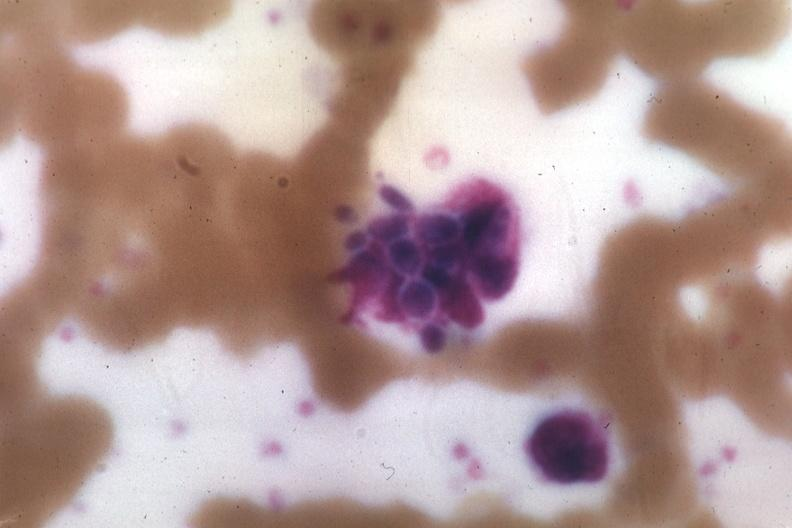what does this image show?
Answer the question using a single word or phrase. Wrights yeast forms 